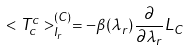<formula> <loc_0><loc_0><loc_500><loc_500>< T _ { c } ^ { c } > _ { I _ { r } } ^ { ( C ) } = - \beta ( \lambda _ { r } ) \frac { \partial } { \partial \lambda _ { r } } L _ { C }</formula> 